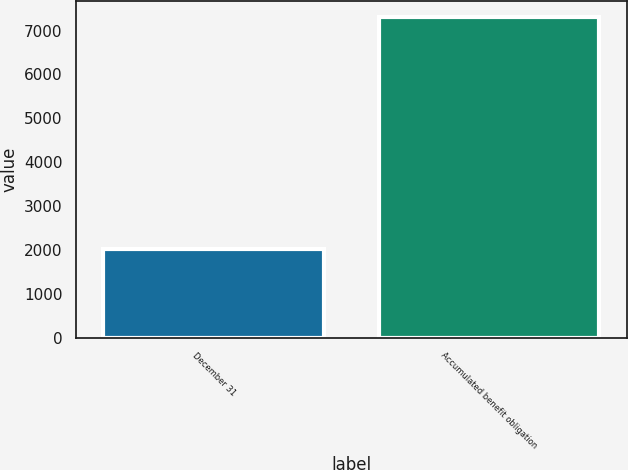Convert chart to OTSL. <chart><loc_0><loc_0><loc_500><loc_500><bar_chart><fcel>December 31<fcel>Accumulated benefit obligation<nl><fcel>2013<fcel>7317<nl></chart> 